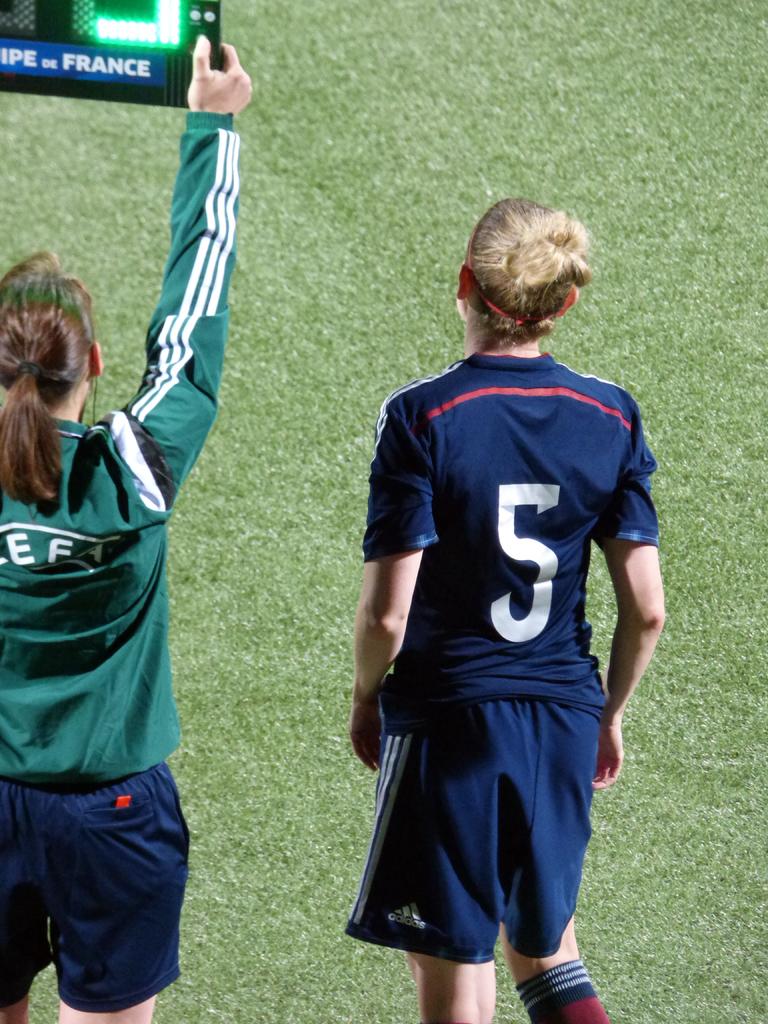What is the color of the female player jersey?
Your response must be concise. Answering does not require reading text in the image. 